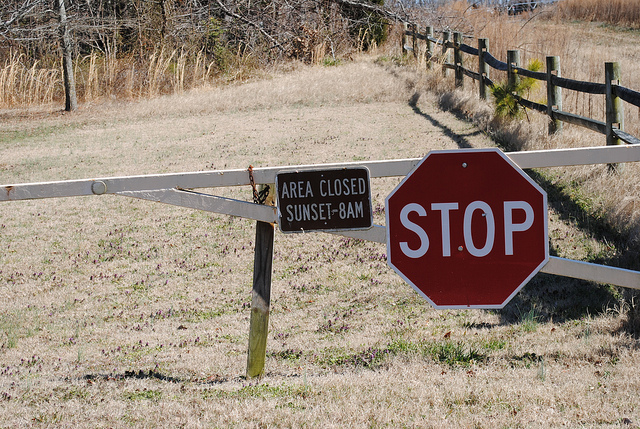Identify and read out the text in this image. CLOSED AREA SUNSET 8AM STOP 